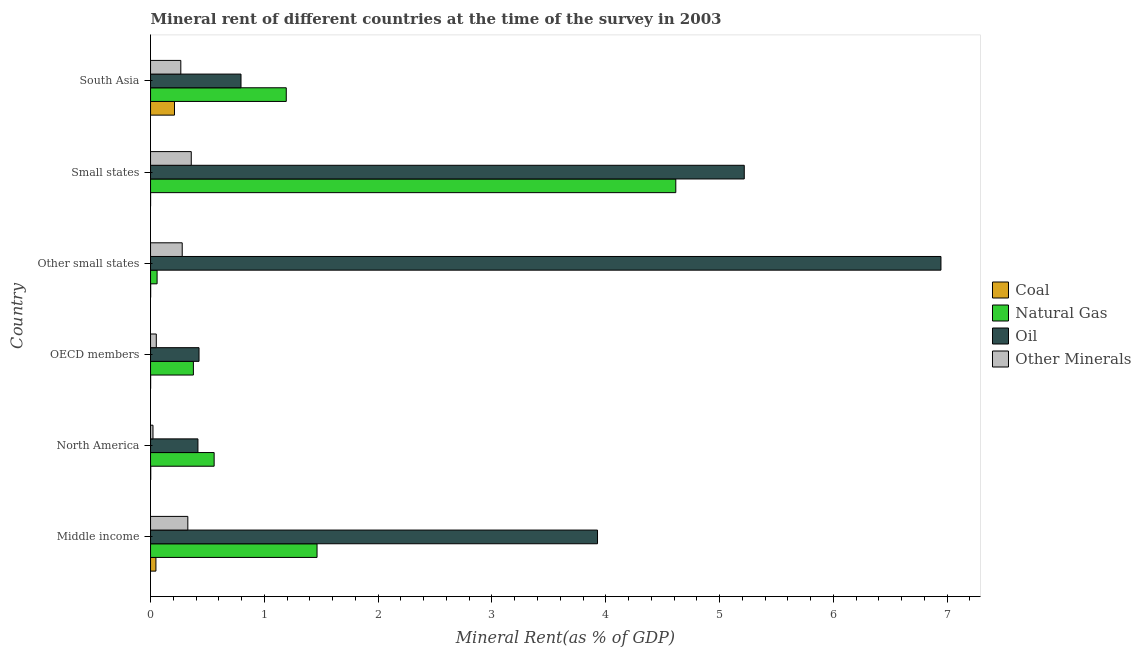How many groups of bars are there?
Your answer should be compact. 6. How many bars are there on the 4th tick from the bottom?
Provide a succinct answer. 4. What is the label of the 3rd group of bars from the top?
Make the answer very short. Other small states. In how many cases, is the number of bars for a given country not equal to the number of legend labels?
Offer a very short reply. 0. What is the natural gas rent in Middle income?
Ensure brevity in your answer.  1.46. Across all countries, what is the maximum  rent of other minerals?
Offer a terse response. 0.36. Across all countries, what is the minimum  rent of other minerals?
Your response must be concise. 0.02. In which country was the oil rent maximum?
Provide a short and direct response. Other small states. What is the total coal rent in the graph?
Offer a very short reply. 0.26. What is the difference between the natural gas rent in Other small states and that in South Asia?
Ensure brevity in your answer.  -1.14. What is the difference between the oil rent in Small states and the natural gas rent in OECD members?
Make the answer very short. 4.84. What is the average  rent of other minerals per country?
Offer a terse response. 0.22. What is the difference between the coal rent and natural gas rent in South Asia?
Keep it short and to the point. -0.98. What is the ratio of the  rent of other minerals in Small states to that in South Asia?
Keep it short and to the point. 1.34. Is the difference between the oil rent in Other small states and South Asia greater than the difference between the natural gas rent in Other small states and South Asia?
Offer a very short reply. Yes. What is the difference between the highest and the second highest  rent of other minerals?
Offer a terse response. 0.03. What is the difference between the highest and the lowest oil rent?
Your response must be concise. 6.53. Is the sum of the natural gas rent in Small states and South Asia greater than the maximum coal rent across all countries?
Your answer should be compact. Yes. Is it the case that in every country, the sum of the coal rent and  rent of other minerals is greater than the sum of natural gas rent and oil rent?
Provide a short and direct response. No. What does the 1st bar from the top in Small states represents?
Ensure brevity in your answer.  Other Minerals. What does the 2nd bar from the bottom in North America represents?
Your response must be concise. Natural Gas. Is it the case that in every country, the sum of the coal rent and natural gas rent is greater than the oil rent?
Provide a short and direct response. No. Are all the bars in the graph horizontal?
Your answer should be compact. Yes. Are the values on the major ticks of X-axis written in scientific E-notation?
Ensure brevity in your answer.  No. What is the title of the graph?
Provide a succinct answer. Mineral rent of different countries at the time of the survey in 2003. Does "Primary" appear as one of the legend labels in the graph?
Your response must be concise. No. What is the label or title of the X-axis?
Give a very brief answer. Mineral Rent(as % of GDP). What is the label or title of the Y-axis?
Provide a short and direct response. Country. What is the Mineral Rent(as % of GDP) of Coal in Middle income?
Your answer should be very brief. 0.05. What is the Mineral Rent(as % of GDP) of Natural Gas in Middle income?
Give a very brief answer. 1.46. What is the Mineral Rent(as % of GDP) of Oil in Middle income?
Ensure brevity in your answer.  3.93. What is the Mineral Rent(as % of GDP) in Other Minerals in Middle income?
Your answer should be compact. 0.33. What is the Mineral Rent(as % of GDP) in Coal in North America?
Make the answer very short. 0. What is the Mineral Rent(as % of GDP) of Natural Gas in North America?
Offer a very short reply. 0.56. What is the Mineral Rent(as % of GDP) of Oil in North America?
Offer a terse response. 0.42. What is the Mineral Rent(as % of GDP) of Other Minerals in North America?
Ensure brevity in your answer.  0.02. What is the Mineral Rent(as % of GDP) in Coal in OECD members?
Keep it short and to the point. 0. What is the Mineral Rent(as % of GDP) in Natural Gas in OECD members?
Provide a succinct answer. 0.38. What is the Mineral Rent(as % of GDP) of Oil in OECD members?
Keep it short and to the point. 0.43. What is the Mineral Rent(as % of GDP) of Other Minerals in OECD members?
Provide a short and direct response. 0.05. What is the Mineral Rent(as % of GDP) in Coal in Other small states?
Offer a terse response. 0. What is the Mineral Rent(as % of GDP) in Natural Gas in Other small states?
Your answer should be very brief. 0.06. What is the Mineral Rent(as % of GDP) of Oil in Other small states?
Provide a succinct answer. 6.95. What is the Mineral Rent(as % of GDP) of Other Minerals in Other small states?
Your response must be concise. 0.28. What is the Mineral Rent(as % of GDP) of Coal in Small states?
Offer a terse response. 0. What is the Mineral Rent(as % of GDP) in Natural Gas in Small states?
Your answer should be compact. 4.62. What is the Mineral Rent(as % of GDP) of Oil in Small states?
Give a very brief answer. 5.22. What is the Mineral Rent(as % of GDP) of Other Minerals in Small states?
Keep it short and to the point. 0.36. What is the Mineral Rent(as % of GDP) in Coal in South Asia?
Provide a succinct answer. 0.21. What is the Mineral Rent(as % of GDP) of Natural Gas in South Asia?
Ensure brevity in your answer.  1.19. What is the Mineral Rent(as % of GDP) of Oil in South Asia?
Provide a short and direct response. 0.79. What is the Mineral Rent(as % of GDP) in Other Minerals in South Asia?
Provide a short and direct response. 0.27. Across all countries, what is the maximum Mineral Rent(as % of GDP) in Coal?
Provide a short and direct response. 0.21. Across all countries, what is the maximum Mineral Rent(as % of GDP) in Natural Gas?
Ensure brevity in your answer.  4.62. Across all countries, what is the maximum Mineral Rent(as % of GDP) in Oil?
Your answer should be compact. 6.95. Across all countries, what is the maximum Mineral Rent(as % of GDP) in Other Minerals?
Your answer should be very brief. 0.36. Across all countries, what is the minimum Mineral Rent(as % of GDP) of Coal?
Provide a succinct answer. 0. Across all countries, what is the minimum Mineral Rent(as % of GDP) in Natural Gas?
Make the answer very short. 0.06. Across all countries, what is the minimum Mineral Rent(as % of GDP) in Oil?
Make the answer very short. 0.42. Across all countries, what is the minimum Mineral Rent(as % of GDP) of Other Minerals?
Keep it short and to the point. 0.02. What is the total Mineral Rent(as % of GDP) in Coal in the graph?
Keep it short and to the point. 0.26. What is the total Mineral Rent(as % of GDP) in Natural Gas in the graph?
Give a very brief answer. 8.26. What is the total Mineral Rent(as % of GDP) of Oil in the graph?
Keep it short and to the point. 17.73. What is the total Mineral Rent(as % of GDP) in Other Minerals in the graph?
Offer a terse response. 1.3. What is the difference between the Mineral Rent(as % of GDP) of Coal in Middle income and that in North America?
Offer a very short reply. 0.05. What is the difference between the Mineral Rent(as % of GDP) of Natural Gas in Middle income and that in North America?
Provide a short and direct response. 0.9. What is the difference between the Mineral Rent(as % of GDP) of Oil in Middle income and that in North America?
Provide a succinct answer. 3.51. What is the difference between the Mineral Rent(as % of GDP) of Other Minerals in Middle income and that in North America?
Offer a terse response. 0.31. What is the difference between the Mineral Rent(as % of GDP) in Coal in Middle income and that in OECD members?
Offer a very short reply. 0.05. What is the difference between the Mineral Rent(as % of GDP) in Natural Gas in Middle income and that in OECD members?
Your answer should be compact. 1.09. What is the difference between the Mineral Rent(as % of GDP) of Oil in Middle income and that in OECD members?
Your answer should be very brief. 3.5. What is the difference between the Mineral Rent(as % of GDP) in Other Minerals in Middle income and that in OECD members?
Provide a short and direct response. 0.28. What is the difference between the Mineral Rent(as % of GDP) in Coal in Middle income and that in Other small states?
Make the answer very short. 0.05. What is the difference between the Mineral Rent(as % of GDP) in Natural Gas in Middle income and that in Other small states?
Ensure brevity in your answer.  1.41. What is the difference between the Mineral Rent(as % of GDP) of Oil in Middle income and that in Other small states?
Provide a succinct answer. -3.02. What is the difference between the Mineral Rent(as % of GDP) in Other Minerals in Middle income and that in Other small states?
Provide a short and direct response. 0.05. What is the difference between the Mineral Rent(as % of GDP) of Coal in Middle income and that in Small states?
Give a very brief answer. 0.05. What is the difference between the Mineral Rent(as % of GDP) of Natural Gas in Middle income and that in Small states?
Keep it short and to the point. -3.15. What is the difference between the Mineral Rent(as % of GDP) of Oil in Middle income and that in Small states?
Offer a very short reply. -1.29. What is the difference between the Mineral Rent(as % of GDP) in Other Minerals in Middle income and that in Small states?
Your answer should be compact. -0.03. What is the difference between the Mineral Rent(as % of GDP) of Coal in Middle income and that in South Asia?
Give a very brief answer. -0.16. What is the difference between the Mineral Rent(as % of GDP) of Natural Gas in Middle income and that in South Asia?
Give a very brief answer. 0.27. What is the difference between the Mineral Rent(as % of GDP) of Oil in Middle income and that in South Asia?
Offer a very short reply. 3.13. What is the difference between the Mineral Rent(as % of GDP) in Other Minerals in Middle income and that in South Asia?
Give a very brief answer. 0.06. What is the difference between the Mineral Rent(as % of GDP) in Coal in North America and that in OECD members?
Provide a short and direct response. 0. What is the difference between the Mineral Rent(as % of GDP) of Natural Gas in North America and that in OECD members?
Ensure brevity in your answer.  0.18. What is the difference between the Mineral Rent(as % of GDP) in Oil in North America and that in OECD members?
Give a very brief answer. -0.01. What is the difference between the Mineral Rent(as % of GDP) of Other Minerals in North America and that in OECD members?
Your response must be concise. -0.03. What is the difference between the Mineral Rent(as % of GDP) of Coal in North America and that in Other small states?
Make the answer very short. 0. What is the difference between the Mineral Rent(as % of GDP) in Natural Gas in North America and that in Other small states?
Keep it short and to the point. 0.5. What is the difference between the Mineral Rent(as % of GDP) of Oil in North America and that in Other small states?
Your answer should be compact. -6.53. What is the difference between the Mineral Rent(as % of GDP) in Other Minerals in North America and that in Other small states?
Provide a short and direct response. -0.26. What is the difference between the Mineral Rent(as % of GDP) of Coal in North America and that in Small states?
Make the answer very short. 0. What is the difference between the Mineral Rent(as % of GDP) of Natural Gas in North America and that in Small states?
Offer a terse response. -4.06. What is the difference between the Mineral Rent(as % of GDP) in Oil in North America and that in Small states?
Keep it short and to the point. -4.8. What is the difference between the Mineral Rent(as % of GDP) in Other Minerals in North America and that in Small states?
Your answer should be very brief. -0.34. What is the difference between the Mineral Rent(as % of GDP) of Coal in North America and that in South Asia?
Keep it short and to the point. -0.21. What is the difference between the Mineral Rent(as % of GDP) in Natural Gas in North America and that in South Asia?
Offer a very short reply. -0.63. What is the difference between the Mineral Rent(as % of GDP) in Oil in North America and that in South Asia?
Provide a short and direct response. -0.38. What is the difference between the Mineral Rent(as % of GDP) of Other Minerals in North America and that in South Asia?
Offer a terse response. -0.24. What is the difference between the Mineral Rent(as % of GDP) in Coal in OECD members and that in Other small states?
Your answer should be compact. -0. What is the difference between the Mineral Rent(as % of GDP) of Natural Gas in OECD members and that in Other small states?
Your answer should be very brief. 0.32. What is the difference between the Mineral Rent(as % of GDP) of Oil in OECD members and that in Other small states?
Keep it short and to the point. -6.52. What is the difference between the Mineral Rent(as % of GDP) in Other Minerals in OECD members and that in Other small states?
Provide a succinct answer. -0.23. What is the difference between the Mineral Rent(as % of GDP) of Coal in OECD members and that in Small states?
Your answer should be very brief. 0. What is the difference between the Mineral Rent(as % of GDP) of Natural Gas in OECD members and that in Small states?
Provide a short and direct response. -4.24. What is the difference between the Mineral Rent(as % of GDP) in Oil in OECD members and that in Small states?
Provide a succinct answer. -4.79. What is the difference between the Mineral Rent(as % of GDP) in Other Minerals in OECD members and that in Small states?
Provide a succinct answer. -0.31. What is the difference between the Mineral Rent(as % of GDP) of Coal in OECD members and that in South Asia?
Offer a terse response. -0.21. What is the difference between the Mineral Rent(as % of GDP) of Natural Gas in OECD members and that in South Asia?
Provide a succinct answer. -0.82. What is the difference between the Mineral Rent(as % of GDP) of Oil in OECD members and that in South Asia?
Provide a short and direct response. -0.37. What is the difference between the Mineral Rent(as % of GDP) of Other Minerals in OECD members and that in South Asia?
Your response must be concise. -0.22. What is the difference between the Mineral Rent(as % of GDP) of Coal in Other small states and that in Small states?
Keep it short and to the point. 0. What is the difference between the Mineral Rent(as % of GDP) of Natural Gas in Other small states and that in Small states?
Give a very brief answer. -4.56. What is the difference between the Mineral Rent(as % of GDP) of Oil in Other small states and that in Small states?
Provide a short and direct response. 1.73. What is the difference between the Mineral Rent(as % of GDP) in Other Minerals in Other small states and that in Small states?
Ensure brevity in your answer.  -0.08. What is the difference between the Mineral Rent(as % of GDP) of Coal in Other small states and that in South Asia?
Offer a very short reply. -0.21. What is the difference between the Mineral Rent(as % of GDP) of Natural Gas in Other small states and that in South Asia?
Provide a short and direct response. -1.14. What is the difference between the Mineral Rent(as % of GDP) in Oil in Other small states and that in South Asia?
Provide a short and direct response. 6.15. What is the difference between the Mineral Rent(as % of GDP) of Other Minerals in Other small states and that in South Asia?
Provide a succinct answer. 0.01. What is the difference between the Mineral Rent(as % of GDP) of Coal in Small states and that in South Asia?
Your answer should be very brief. -0.21. What is the difference between the Mineral Rent(as % of GDP) of Natural Gas in Small states and that in South Asia?
Offer a very short reply. 3.42. What is the difference between the Mineral Rent(as % of GDP) in Oil in Small states and that in South Asia?
Your answer should be compact. 4.42. What is the difference between the Mineral Rent(as % of GDP) in Other Minerals in Small states and that in South Asia?
Offer a very short reply. 0.09. What is the difference between the Mineral Rent(as % of GDP) in Coal in Middle income and the Mineral Rent(as % of GDP) in Natural Gas in North America?
Provide a succinct answer. -0.51. What is the difference between the Mineral Rent(as % of GDP) in Coal in Middle income and the Mineral Rent(as % of GDP) in Oil in North America?
Make the answer very short. -0.37. What is the difference between the Mineral Rent(as % of GDP) in Coal in Middle income and the Mineral Rent(as % of GDP) in Other Minerals in North America?
Provide a succinct answer. 0.03. What is the difference between the Mineral Rent(as % of GDP) of Natural Gas in Middle income and the Mineral Rent(as % of GDP) of Oil in North America?
Keep it short and to the point. 1.05. What is the difference between the Mineral Rent(as % of GDP) of Natural Gas in Middle income and the Mineral Rent(as % of GDP) of Other Minerals in North America?
Give a very brief answer. 1.44. What is the difference between the Mineral Rent(as % of GDP) of Oil in Middle income and the Mineral Rent(as % of GDP) of Other Minerals in North America?
Your answer should be very brief. 3.91. What is the difference between the Mineral Rent(as % of GDP) of Coal in Middle income and the Mineral Rent(as % of GDP) of Natural Gas in OECD members?
Ensure brevity in your answer.  -0.33. What is the difference between the Mineral Rent(as % of GDP) in Coal in Middle income and the Mineral Rent(as % of GDP) in Oil in OECD members?
Make the answer very short. -0.38. What is the difference between the Mineral Rent(as % of GDP) in Coal in Middle income and the Mineral Rent(as % of GDP) in Other Minerals in OECD members?
Ensure brevity in your answer.  -0. What is the difference between the Mineral Rent(as % of GDP) in Natural Gas in Middle income and the Mineral Rent(as % of GDP) in Oil in OECD members?
Your answer should be very brief. 1.04. What is the difference between the Mineral Rent(as % of GDP) in Natural Gas in Middle income and the Mineral Rent(as % of GDP) in Other Minerals in OECD members?
Your answer should be very brief. 1.41. What is the difference between the Mineral Rent(as % of GDP) of Oil in Middle income and the Mineral Rent(as % of GDP) of Other Minerals in OECD members?
Ensure brevity in your answer.  3.88. What is the difference between the Mineral Rent(as % of GDP) in Coal in Middle income and the Mineral Rent(as % of GDP) in Natural Gas in Other small states?
Your answer should be compact. -0.01. What is the difference between the Mineral Rent(as % of GDP) in Coal in Middle income and the Mineral Rent(as % of GDP) in Oil in Other small states?
Your answer should be compact. -6.9. What is the difference between the Mineral Rent(as % of GDP) of Coal in Middle income and the Mineral Rent(as % of GDP) of Other Minerals in Other small states?
Your answer should be very brief. -0.23. What is the difference between the Mineral Rent(as % of GDP) of Natural Gas in Middle income and the Mineral Rent(as % of GDP) of Oil in Other small states?
Keep it short and to the point. -5.48. What is the difference between the Mineral Rent(as % of GDP) of Natural Gas in Middle income and the Mineral Rent(as % of GDP) of Other Minerals in Other small states?
Your answer should be compact. 1.18. What is the difference between the Mineral Rent(as % of GDP) in Oil in Middle income and the Mineral Rent(as % of GDP) in Other Minerals in Other small states?
Offer a very short reply. 3.65. What is the difference between the Mineral Rent(as % of GDP) of Coal in Middle income and the Mineral Rent(as % of GDP) of Natural Gas in Small states?
Your response must be concise. -4.57. What is the difference between the Mineral Rent(as % of GDP) of Coal in Middle income and the Mineral Rent(as % of GDP) of Oil in Small states?
Provide a succinct answer. -5.17. What is the difference between the Mineral Rent(as % of GDP) of Coal in Middle income and the Mineral Rent(as % of GDP) of Other Minerals in Small states?
Keep it short and to the point. -0.31. What is the difference between the Mineral Rent(as % of GDP) of Natural Gas in Middle income and the Mineral Rent(as % of GDP) of Oil in Small states?
Provide a succinct answer. -3.75. What is the difference between the Mineral Rent(as % of GDP) in Natural Gas in Middle income and the Mineral Rent(as % of GDP) in Other Minerals in Small states?
Your answer should be very brief. 1.11. What is the difference between the Mineral Rent(as % of GDP) of Oil in Middle income and the Mineral Rent(as % of GDP) of Other Minerals in Small states?
Offer a very short reply. 3.57. What is the difference between the Mineral Rent(as % of GDP) in Coal in Middle income and the Mineral Rent(as % of GDP) in Natural Gas in South Asia?
Keep it short and to the point. -1.15. What is the difference between the Mineral Rent(as % of GDP) in Coal in Middle income and the Mineral Rent(as % of GDP) in Oil in South Asia?
Your response must be concise. -0.75. What is the difference between the Mineral Rent(as % of GDP) in Coal in Middle income and the Mineral Rent(as % of GDP) in Other Minerals in South Asia?
Your answer should be compact. -0.22. What is the difference between the Mineral Rent(as % of GDP) in Natural Gas in Middle income and the Mineral Rent(as % of GDP) in Oil in South Asia?
Give a very brief answer. 0.67. What is the difference between the Mineral Rent(as % of GDP) in Natural Gas in Middle income and the Mineral Rent(as % of GDP) in Other Minerals in South Asia?
Your answer should be compact. 1.2. What is the difference between the Mineral Rent(as % of GDP) in Oil in Middle income and the Mineral Rent(as % of GDP) in Other Minerals in South Asia?
Offer a terse response. 3.66. What is the difference between the Mineral Rent(as % of GDP) of Coal in North America and the Mineral Rent(as % of GDP) of Natural Gas in OECD members?
Give a very brief answer. -0.37. What is the difference between the Mineral Rent(as % of GDP) in Coal in North America and the Mineral Rent(as % of GDP) in Oil in OECD members?
Provide a succinct answer. -0.42. What is the difference between the Mineral Rent(as % of GDP) of Coal in North America and the Mineral Rent(as % of GDP) of Other Minerals in OECD members?
Give a very brief answer. -0.05. What is the difference between the Mineral Rent(as % of GDP) in Natural Gas in North America and the Mineral Rent(as % of GDP) in Oil in OECD members?
Your answer should be very brief. 0.13. What is the difference between the Mineral Rent(as % of GDP) in Natural Gas in North America and the Mineral Rent(as % of GDP) in Other Minerals in OECD members?
Your answer should be compact. 0.51. What is the difference between the Mineral Rent(as % of GDP) in Oil in North America and the Mineral Rent(as % of GDP) in Other Minerals in OECD members?
Ensure brevity in your answer.  0.37. What is the difference between the Mineral Rent(as % of GDP) of Coal in North America and the Mineral Rent(as % of GDP) of Natural Gas in Other small states?
Your answer should be very brief. -0.06. What is the difference between the Mineral Rent(as % of GDP) of Coal in North America and the Mineral Rent(as % of GDP) of Oil in Other small states?
Offer a very short reply. -6.94. What is the difference between the Mineral Rent(as % of GDP) in Coal in North America and the Mineral Rent(as % of GDP) in Other Minerals in Other small states?
Your response must be concise. -0.28. What is the difference between the Mineral Rent(as % of GDP) in Natural Gas in North America and the Mineral Rent(as % of GDP) in Oil in Other small states?
Provide a succinct answer. -6.39. What is the difference between the Mineral Rent(as % of GDP) in Natural Gas in North America and the Mineral Rent(as % of GDP) in Other Minerals in Other small states?
Make the answer very short. 0.28. What is the difference between the Mineral Rent(as % of GDP) in Oil in North America and the Mineral Rent(as % of GDP) in Other Minerals in Other small states?
Your response must be concise. 0.14. What is the difference between the Mineral Rent(as % of GDP) in Coal in North America and the Mineral Rent(as % of GDP) in Natural Gas in Small states?
Offer a terse response. -4.61. What is the difference between the Mineral Rent(as % of GDP) of Coal in North America and the Mineral Rent(as % of GDP) of Oil in Small states?
Give a very brief answer. -5.22. What is the difference between the Mineral Rent(as % of GDP) in Coal in North America and the Mineral Rent(as % of GDP) in Other Minerals in Small states?
Provide a succinct answer. -0.36. What is the difference between the Mineral Rent(as % of GDP) of Natural Gas in North America and the Mineral Rent(as % of GDP) of Oil in Small states?
Your response must be concise. -4.66. What is the difference between the Mineral Rent(as % of GDP) of Natural Gas in North America and the Mineral Rent(as % of GDP) of Other Minerals in Small states?
Your answer should be compact. 0.2. What is the difference between the Mineral Rent(as % of GDP) in Oil in North America and the Mineral Rent(as % of GDP) in Other Minerals in Small states?
Keep it short and to the point. 0.06. What is the difference between the Mineral Rent(as % of GDP) of Coal in North America and the Mineral Rent(as % of GDP) of Natural Gas in South Asia?
Keep it short and to the point. -1.19. What is the difference between the Mineral Rent(as % of GDP) of Coal in North America and the Mineral Rent(as % of GDP) of Oil in South Asia?
Ensure brevity in your answer.  -0.79. What is the difference between the Mineral Rent(as % of GDP) of Coal in North America and the Mineral Rent(as % of GDP) of Other Minerals in South Asia?
Give a very brief answer. -0.26. What is the difference between the Mineral Rent(as % of GDP) in Natural Gas in North America and the Mineral Rent(as % of GDP) in Oil in South Asia?
Ensure brevity in your answer.  -0.24. What is the difference between the Mineral Rent(as % of GDP) in Natural Gas in North America and the Mineral Rent(as % of GDP) in Other Minerals in South Asia?
Provide a short and direct response. 0.29. What is the difference between the Mineral Rent(as % of GDP) of Oil in North America and the Mineral Rent(as % of GDP) of Other Minerals in South Asia?
Offer a very short reply. 0.15. What is the difference between the Mineral Rent(as % of GDP) of Coal in OECD members and the Mineral Rent(as % of GDP) of Natural Gas in Other small states?
Your response must be concise. -0.06. What is the difference between the Mineral Rent(as % of GDP) in Coal in OECD members and the Mineral Rent(as % of GDP) in Oil in Other small states?
Provide a succinct answer. -6.94. What is the difference between the Mineral Rent(as % of GDP) in Coal in OECD members and the Mineral Rent(as % of GDP) in Other Minerals in Other small states?
Your answer should be compact. -0.28. What is the difference between the Mineral Rent(as % of GDP) of Natural Gas in OECD members and the Mineral Rent(as % of GDP) of Oil in Other small states?
Make the answer very short. -6.57. What is the difference between the Mineral Rent(as % of GDP) of Natural Gas in OECD members and the Mineral Rent(as % of GDP) of Other Minerals in Other small states?
Make the answer very short. 0.1. What is the difference between the Mineral Rent(as % of GDP) of Oil in OECD members and the Mineral Rent(as % of GDP) of Other Minerals in Other small states?
Provide a short and direct response. 0.15. What is the difference between the Mineral Rent(as % of GDP) of Coal in OECD members and the Mineral Rent(as % of GDP) of Natural Gas in Small states?
Give a very brief answer. -4.61. What is the difference between the Mineral Rent(as % of GDP) of Coal in OECD members and the Mineral Rent(as % of GDP) of Oil in Small states?
Your answer should be compact. -5.22. What is the difference between the Mineral Rent(as % of GDP) of Coal in OECD members and the Mineral Rent(as % of GDP) of Other Minerals in Small states?
Provide a succinct answer. -0.36. What is the difference between the Mineral Rent(as % of GDP) in Natural Gas in OECD members and the Mineral Rent(as % of GDP) in Oil in Small states?
Your answer should be very brief. -4.84. What is the difference between the Mineral Rent(as % of GDP) in Natural Gas in OECD members and the Mineral Rent(as % of GDP) in Other Minerals in Small states?
Your answer should be compact. 0.02. What is the difference between the Mineral Rent(as % of GDP) of Oil in OECD members and the Mineral Rent(as % of GDP) of Other Minerals in Small states?
Your answer should be compact. 0.07. What is the difference between the Mineral Rent(as % of GDP) of Coal in OECD members and the Mineral Rent(as % of GDP) of Natural Gas in South Asia?
Ensure brevity in your answer.  -1.19. What is the difference between the Mineral Rent(as % of GDP) of Coal in OECD members and the Mineral Rent(as % of GDP) of Oil in South Asia?
Your response must be concise. -0.79. What is the difference between the Mineral Rent(as % of GDP) of Coal in OECD members and the Mineral Rent(as % of GDP) of Other Minerals in South Asia?
Give a very brief answer. -0.27. What is the difference between the Mineral Rent(as % of GDP) of Natural Gas in OECD members and the Mineral Rent(as % of GDP) of Oil in South Asia?
Your answer should be very brief. -0.42. What is the difference between the Mineral Rent(as % of GDP) of Natural Gas in OECD members and the Mineral Rent(as % of GDP) of Other Minerals in South Asia?
Make the answer very short. 0.11. What is the difference between the Mineral Rent(as % of GDP) in Oil in OECD members and the Mineral Rent(as % of GDP) in Other Minerals in South Asia?
Provide a succinct answer. 0.16. What is the difference between the Mineral Rent(as % of GDP) of Coal in Other small states and the Mineral Rent(as % of GDP) of Natural Gas in Small states?
Your answer should be very brief. -4.61. What is the difference between the Mineral Rent(as % of GDP) of Coal in Other small states and the Mineral Rent(as % of GDP) of Oil in Small states?
Provide a short and direct response. -5.22. What is the difference between the Mineral Rent(as % of GDP) in Coal in Other small states and the Mineral Rent(as % of GDP) in Other Minerals in Small states?
Your answer should be compact. -0.36. What is the difference between the Mineral Rent(as % of GDP) of Natural Gas in Other small states and the Mineral Rent(as % of GDP) of Oil in Small states?
Keep it short and to the point. -5.16. What is the difference between the Mineral Rent(as % of GDP) in Natural Gas in Other small states and the Mineral Rent(as % of GDP) in Other Minerals in Small states?
Make the answer very short. -0.3. What is the difference between the Mineral Rent(as % of GDP) in Oil in Other small states and the Mineral Rent(as % of GDP) in Other Minerals in Small states?
Make the answer very short. 6.59. What is the difference between the Mineral Rent(as % of GDP) of Coal in Other small states and the Mineral Rent(as % of GDP) of Natural Gas in South Asia?
Offer a terse response. -1.19. What is the difference between the Mineral Rent(as % of GDP) of Coal in Other small states and the Mineral Rent(as % of GDP) of Oil in South Asia?
Your answer should be very brief. -0.79. What is the difference between the Mineral Rent(as % of GDP) of Coal in Other small states and the Mineral Rent(as % of GDP) of Other Minerals in South Asia?
Your answer should be very brief. -0.26. What is the difference between the Mineral Rent(as % of GDP) of Natural Gas in Other small states and the Mineral Rent(as % of GDP) of Oil in South Asia?
Keep it short and to the point. -0.74. What is the difference between the Mineral Rent(as % of GDP) in Natural Gas in Other small states and the Mineral Rent(as % of GDP) in Other Minerals in South Asia?
Your response must be concise. -0.21. What is the difference between the Mineral Rent(as % of GDP) in Oil in Other small states and the Mineral Rent(as % of GDP) in Other Minerals in South Asia?
Give a very brief answer. 6.68. What is the difference between the Mineral Rent(as % of GDP) in Coal in Small states and the Mineral Rent(as % of GDP) in Natural Gas in South Asia?
Your answer should be compact. -1.19. What is the difference between the Mineral Rent(as % of GDP) of Coal in Small states and the Mineral Rent(as % of GDP) of Oil in South Asia?
Your answer should be very brief. -0.79. What is the difference between the Mineral Rent(as % of GDP) in Coal in Small states and the Mineral Rent(as % of GDP) in Other Minerals in South Asia?
Your answer should be compact. -0.27. What is the difference between the Mineral Rent(as % of GDP) of Natural Gas in Small states and the Mineral Rent(as % of GDP) of Oil in South Asia?
Give a very brief answer. 3.82. What is the difference between the Mineral Rent(as % of GDP) of Natural Gas in Small states and the Mineral Rent(as % of GDP) of Other Minerals in South Asia?
Provide a succinct answer. 4.35. What is the difference between the Mineral Rent(as % of GDP) of Oil in Small states and the Mineral Rent(as % of GDP) of Other Minerals in South Asia?
Offer a terse response. 4.95. What is the average Mineral Rent(as % of GDP) of Coal per country?
Your answer should be compact. 0.04. What is the average Mineral Rent(as % of GDP) in Natural Gas per country?
Provide a succinct answer. 1.38. What is the average Mineral Rent(as % of GDP) of Oil per country?
Provide a succinct answer. 2.95. What is the average Mineral Rent(as % of GDP) in Other Minerals per country?
Offer a very short reply. 0.22. What is the difference between the Mineral Rent(as % of GDP) of Coal and Mineral Rent(as % of GDP) of Natural Gas in Middle income?
Provide a short and direct response. -1.42. What is the difference between the Mineral Rent(as % of GDP) in Coal and Mineral Rent(as % of GDP) in Oil in Middle income?
Your answer should be very brief. -3.88. What is the difference between the Mineral Rent(as % of GDP) of Coal and Mineral Rent(as % of GDP) of Other Minerals in Middle income?
Make the answer very short. -0.28. What is the difference between the Mineral Rent(as % of GDP) in Natural Gas and Mineral Rent(as % of GDP) in Oil in Middle income?
Your answer should be very brief. -2.46. What is the difference between the Mineral Rent(as % of GDP) of Natural Gas and Mineral Rent(as % of GDP) of Other Minerals in Middle income?
Make the answer very short. 1.14. What is the difference between the Mineral Rent(as % of GDP) of Oil and Mineral Rent(as % of GDP) of Other Minerals in Middle income?
Keep it short and to the point. 3.6. What is the difference between the Mineral Rent(as % of GDP) in Coal and Mineral Rent(as % of GDP) in Natural Gas in North America?
Your response must be concise. -0.56. What is the difference between the Mineral Rent(as % of GDP) of Coal and Mineral Rent(as % of GDP) of Oil in North America?
Make the answer very short. -0.41. What is the difference between the Mineral Rent(as % of GDP) in Coal and Mineral Rent(as % of GDP) in Other Minerals in North America?
Keep it short and to the point. -0.02. What is the difference between the Mineral Rent(as % of GDP) in Natural Gas and Mineral Rent(as % of GDP) in Oil in North America?
Your answer should be very brief. 0.14. What is the difference between the Mineral Rent(as % of GDP) in Natural Gas and Mineral Rent(as % of GDP) in Other Minerals in North America?
Make the answer very short. 0.54. What is the difference between the Mineral Rent(as % of GDP) of Oil and Mineral Rent(as % of GDP) of Other Minerals in North America?
Ensure brevity in your answer.  0.4. What is the difference between the Mineral Rent(as % of GDP) in Coal and Mineral Rent(as % of GDP) in Natural Gas in OECD members?
Ensure brevity in your answer.  -0.38. What is the difference between the Mineral Rent(as % of GDP) of Coal and Mineral Rent(as % of GDP) of Oil in OECD members?
Offer a very short reply. -0.43. What is the difference between the Mineral Rent(as % of GDP) in Coal and Mineral Rent(as % of GDP) in Other Minerals in OECD members?
Ensure brevity in your answer.  -0.05. What is the difference between the Mineral Rent(as % of GDP) in Natural Gas and Mineral Rent(as % of GDP) in Oil in OECD members?
Offer a very short reply. -0.05. What is the difference between the Mineral Rent(as % of GDP) in Natural Gas and Mineral Rent(as % of GDP) in Other Minerals in OECD members?
Offer a very short reply. 0.33. What is the difference between the Mineral Rent(as % of GDP) of Oil and Mineral Rent(as % of GDP) of Other Minerals in OECD members?
Your response must be concise. 0.38. What is the difference between the Mineral Rent(as % of GDP) in Coal and Mineral Rent(as % of GDP) in Natural Gas in Other small states?
Offer a very short reply. -0.06. What is the difference between the Mineral Rent(as % of GDP) of Coal and Mineral Rent(as % of GDP) of Oil in Other small states?
Your answer should be very brief. -6.94. What is the difference between the Mineral Rent(as % of GDP) in Coal and Mineral Rent(as % of GDP) in Other Minerals in Other small states?
Give a very brief answer. -0.28. What is the difference between the Mineral Rent(as % of GDP) in Natural Gas and Mineral Rent(as % of GDP) in Oil in Other small states?
Ensure brevity in your answer.  -6.89. What is the difference between the Mineral Rent(as % of GDP) of Natural Gas and Mineral Rent(as % of GDP) of Other Minerals in Other small states?
Offer a terse response. -0.22. What is the difference between the Mineral Rent(as % of GDP) in Oil and Mineral Rent(as % of GDP) in Other Minerals in Other small states?
Offer a very short reply. 6.67. What is the difference between the Mineral Rent(as % of GDP) of Coal and Mineral Rent(as % of GDP) of Natural Gas in Small states?
Keep it short and to the point. -4.61. What is the difference between the Mineral Rent(as % of GDP) in Coal and Mineral Rent(as % of GDP) in Oil in Small states?
Your response must be concise. -5.22. What is the difference between the Mineral Rent(as % of GDP) of Coal and Mineral Rent(as % of GDP) of Other Minerals in Small states?
Provide a short and direct response. -0.36. What is the difference between the Mineral Rent(as % of GDP) of Natural Gas and Mineral Rent(as % of GDP) of Oil in Small states?
Keep it short and to the point. -0.6. What is the difference between the Mineral Rent(as % of GDP) in Natural Gas and Mineral Rent(as % of GDP) in Other Minerals in Small states?
Your response must be concise. 4.26. What is the difference between the Mineral Rent(as % of GDP) in Oil and Mineral Rent(as % of GDP) in Other Minerals in Small states?
Your answer should be compact. 4.86. What is the difference between the Mineral Rent(as % of GDP) in Coal and Mineral Rent(as % of GDP) in Natural Gas in South Asia?
Make the answer very short. -0.98. What is the difference between the Mineral Rent(as % of GDP) of Coal and Mineral Rent(as % of GDP) of Oil in South Asia?
Your answer should be very brief. -0.58. What is the difference between the Mineral Rent(as % of GDP) in Coal and Mineral Rent(as % of GDP) in Other Minerals in South Asia?
Your answer should be compact. -0.06. What is the difference between the Mineral Rent(as % of GDP) in Natural Gas and Mineral Rent(as % of GDP) in Oil in South Asia?
Ensure brevity in your answer.  0.4. What is the difference between the Mineral Rent(as % of GDP) of Natural Gas and Mineral Rent(as % of GDP) of Other Minerals in South Asia?
Keep it short and to the point. 0.93. What is the difference between the Mineral Rent(as % of GDP) in Oil and Mineral Rent(as % of GDP) in Other Minerals in South Asia?
Offer a very short reply. 0.53. What is the ratio of the Mineral Rent(as % of GDP) of Coal in Middle income to that in North America?
Your response must be concise. 25.48. What is the ratio of the Mineral Rent(as % of GDP) of Natural Gas in Middle income to that in North America?
Make the answer very short. 2.62. What is the ratio of the Mineral Rent(as % of GDP) in Oil in Middle income to that in North America?
Offer a terse response. 9.43. What is the ratio of the Mineral Rent(as % of GDP) of Other Minerals in Middle income to that in North America?
Offer a terse response. 15.22. What is the ratio of the Mineral Rent(as % of GDP) in Coal in Middle income to that in OECD members?
Offer a terse response. 51.24. What is the ratio of the Mineral Rent(as % of GDP) in Natural Gas in Middle income to that in OECD members?
Offer a terse response. 3.89. What is the ratio of the Mineral Rent(as % of GDP) in Oil in Middle income to that in OECD members?
Keep it short and to the point. 9.22. What is the ratio of the Mineral Rent(as % of GDP) of Other Minerals in Middle income to that in OECD members?
Your response must be concise. 6.48. What is the ratio of the Mineral Rent(as % of GDP) in Coal in Middle income to that in Other small states?
Provide a succinct answer. 40.51. What is the ratio of the Mineral Rent(as % of GDP) in Natural Gas in Middle income to that in Other small states?
Provide a succinct answer. 25.42. What is the ratio of the Mineral Rent(as % of GDP) of Oil in Middle income to that in Other small states?
Offer a very short reply. 0.57. What is the ratio of the Mineral Rent(as % of GDP) in Other Minerals in Middle income to that in Other small states?
Provide a short and direct response. 1.18. What is the ratio of the Mineral Rent(as % of GDP) of Coal in Middle income to that in Small states?
Offer a very short reply. 89.07. What is the ratio of the Mineral Rent(as % of GDP) in Natural Gas in Middle income to that in Small states?
Offer a terse response. 0.32. What is the ratio of the Mineral Rent(as % of GDP) of Oil in Middle income to that in Small states?
Give a very brief answer. 0.75. What is the ratio of the Mineral Rent(as % of GDP) in Other Minerals in Middle income to that in Small states?
Make the answer very short. 0.92. What is the ratio of the Mineral Rent(as % of GDP) in Coal in Middle income to that in South Asia?
Offer a terse response. 0.22. What is the ratio of the Mineral Rent(as % of GDP) of Natural Gas in Middle income to that in South Asia?
Provide a succinct answer. 1.23. What is the ratio of the Mineral Rent(as % of GDP) of Oil in Middle income to that in South Asia?
Your answer should be compact. 4.94. What is the ratio of the Mineral Rent(as % of GDP) in Other Minerals in Middle income to that in South Asia?
Ensure brevity in your answer.  1.23. What is the ratio of the Mineral Rent(as % of GDP) in Coal in North America to that in OECD members?
Offer a very short reply. 2.01. What is the ratio of the Mineral Rent(as % of GDP) in Natural Gas in North America to that in OECD members?
Make the answer very short. 1.48. What is the ratio of the Mineral Rent(as % of GDP) of Oil in North America to that in OECD members?
Your answer should be compact. 0.98. What is the ratio of the Mineral Rent(as % of GDP) of Other Minerals in North America to that in OECD members?
Give a very brief answer. 0.43. What is the ratio of the Mineral Rent(as % of GDP) in Coal in North America to that in Other small states?
Your answer should be compact. 1.59. What is the ratio of the Mineral Rent(as % of GDP) of Natural Gas in North America to that in Other small states?
Give a very brief answer. 9.71. What is the ratio of the Mineral Rent(as % of GDP) of Oil in North America to that in Other small states?
Your answer should be compact. 0.06. What is the ratio of the Mineral Rent(as % of GDP) of Other Minerals in North America to that in Other small states?
Your response must be concise. 0.08. What is the ratio of the Mineral Rent(as % of GDP) in Coal in North America to that in Small states?
Offer a terse response. 3.5. What is the ratio of the Mineral Rent(as % of GDP) of Natural Gas in North America to that in Small states?
Provide a short and direct response. 0.12. What is the ratio of the Mineral Rent(as % of GDP) in Oil in North America to that in Small states?
Offer a very short reply. 0.08. What is the ratio of the Mineral Rent(as % of GDP) in Other Minerals in North America to that in Small states?
Your answer should be compact. 0.06. What is the ratio of the Mineral Rent(as % of GDP) in Coal in North America to that in South Asia?
Your answer should be very brief. 0.01. What is the ratio of the Mineral Rent(as % of GDP) in Natural Gas in North America to that in South Asia?
Ensure brevity in your answer.  0.47. What is the ratio of the Mineral Rent(as % of GDP) of Oil in North America to that in South Asia?
Ensure brevity in your answer.  0.52. What is the ratio of the Mineral Rent(as % of GDP) of Other Minerals in North America to that in South Asia?
Keep it short and to the point. 0.08. What is the ratio of the Mineral Rent(as % of GDP) in Coal in OECD members to that in Other small states?
Give a very brief answer. 0.79. What is the ratio of the Mineral Rent(as % of GDP) of Natural Gas in OECD members to that in Other small states?
Make the answer very short. 6.54. What is the ratio of the Mineral Rent(as % of GDP) in Oil in OECD members to that in Other small states?
Ensure brevity in your answer.  0.06. What is the ratio of the Mineral Rent(as % of GDP) of Other Minerals in OECD members to that in Other small states?
Offer a terse response. 0.18. What is the ratio of the Mineral Rent(as % of GDP) of Coal in OECD members to that in Small states?
Your answer should be compact. 1.74. What is the ratio of the Mineral Rent(as % of GDP) of Natural Gas in OECD members to that in Small states?
Keep it short and to the point. 0.08. What is the ratio of the Mineral Rent(as % of GDP) in Oil in OECD members to that in Small states?
Give a very brief answer. 0.08. What is the ratio of the Mineral Rent(as % of GDP) of Other Minerals in OECD members to that in Small states?
Ensure brevity in your answer.  0.14. What is the ratio of the Mineral Rent(as % of GDP) of Coal in OECD members to that in South Asia?
Your answer should be very brief. 0. What is the ratio of the Mineral Rent(as % of GDP) in Natural Gas in OECD members to that in South Asia?
Provide a succinct answer. 0.32. What is the ratio of the Mineral Rent(as % of GDP) in Oil in OECD members to that in South Asia?
Provide a short and direct response. 0.54. What is the ratio of the Mineral Rent(as % of GDP) in Other Minerals in OECD members to that in South Asia?
Your answer should be compact. 0.19. What is the ratio of the Mineral Rent(as % of GDP) of Coal in Other small states to that in Small states?
Make the answer very short. 2.2. What is the ratio of the Mineral Rent(as % of GDP) in Natural Gas in Other small states to that in Small states?
Give a very brief answer. 0.01. What is the ratio of the Mineral Rent(as % of GDP) in Oil in Other small states to that in Small states?
Make the answer very short. 1.33. What is the ratio of the Mineral Rent(as % of GDP) in Other Minerals in Other small states to that in Small states?
Keep it short and to the point. 0.78. What is the ratio of the Mineral Rent(as % of GDP) of Coal in Other small states to that in South Asia?
Your answer should be compact. 0.01. What is the ratio of the Mineral Rent(as % of GDP) of Natural Gas in Other small states to that in South Asia?
Ensure brevity in your answer.  0.05. What is the ratio of the Mineral Rent(as % of GDP) of Oil in Other small states to that in South Asia?
Make the answer very short. 8.74. What is the ratio of the Mineral Rent(as % of GDP) in Other Minerals in Other small states to that in South Asia?
Provide a succinct answer. 1.05. What is the ratio of the Mineral Rent(as % of GDP) in Coal in Small states to that in South Asia?
Make the answer very short. 0. What is the ratio of the Mineral Rent(as % of GDP) in Natural Gas in Small states to that in South Asia?
Your answer should be very brief. 3.87. What is the ratio of the Mineral Rent(as % of GDP) of Oil in Small states to that in South Asia?
Give a very brief answer. 6.56. What is the ratio of the Mineral Rent(as % of GDP) of Other Minerals in Small states to that in South Asia?
Make the answer very short. 1.34. What is the difference between the highest and the second highest Mineral Rent(as % of GDP) in Coal?
Your answer should be compact. 0.16. What is the difference between the highest and the second highest Mineral Rent(as % of GDP) of Natural Gas?
Provide a succinct answer. 3.15. What is the difference between the highest and the second highest Mineral Rent(as % of GDP) of Oil?
Provide a short and direct response. 1.73. What is the difference between the highest and the second highest Mineral Rent(as % of GDP) of Other Minerals?
Keep it short and to the point. 0.03. What is the difference between the highest and the lowest Mineral Rent(as % of GDP) of Coal?
Offer a very short reply. 0.21. What is the difference between the highest and the lowest Mineral Rent(as % of GDP) of Natural Gas?
Provide a succinct answer. 4.56. What is the difference between the highest and the lowest Mineral Rent(as % of GDP) of Oil?
Your response must be concise. 6.53. What is the difference between the highest and the lowest Mineral Rent(as % of GDP) in Other Minerals?
Your answer should be very brief. 0.34. 